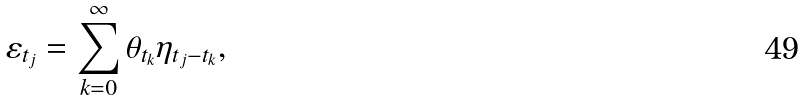<formula> <loc_0><loc_0><loc_500><loc_500>\varepsilon _ { t _ { j } } = \sum _ { k = 0 } ^ { \infty } \theta _ { t _ { k } } \eta _ { t _ { j } - t _ { k } } ,</formula> 